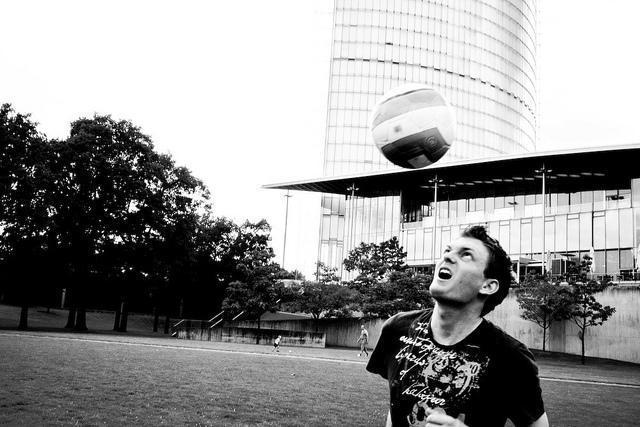How many umbrellas have more than 4 colors?
Give a very brief answer. 0. 